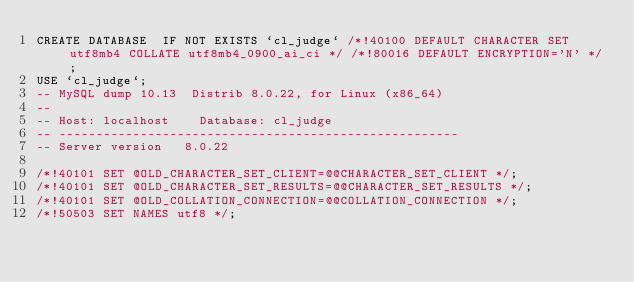Convert code to text. <code><loc_0><loc_0><loc_500><loc_500><_SQL_>CREATE DATABASE  IF NOT EXISTS `cl_judge` /*!40100 DEFAULT CHARACTER SET utf8mb4 COLLATE utf8mb4_0900_ai_ci */ /*!80016 DEFAULT ENCRYPTION='N' */;
USE `cl_judge`;
-- MySQL dump 10.13  Distrib 8.0.22, for Linux (x86_64)
--
-- Host: localhost    Database: cl_judge
-- ------------------------------------------------------
-- Server version	8.0.22

/*!40101 SET @OLD_CHARACTER_SET_CLIENT=@@CHARACTER_SET_CLIENT */;
/*!40101 SET @OLD_CHARACTER_SET_RESULTS=@@CHARACTER_SET_RESULTS */;
/*!40101 SET @OLD_COLLATION_CONNECTION=@@COLLATION_CONNECTION */;
/*!50503 SET NAMES utf8 */;</code> 